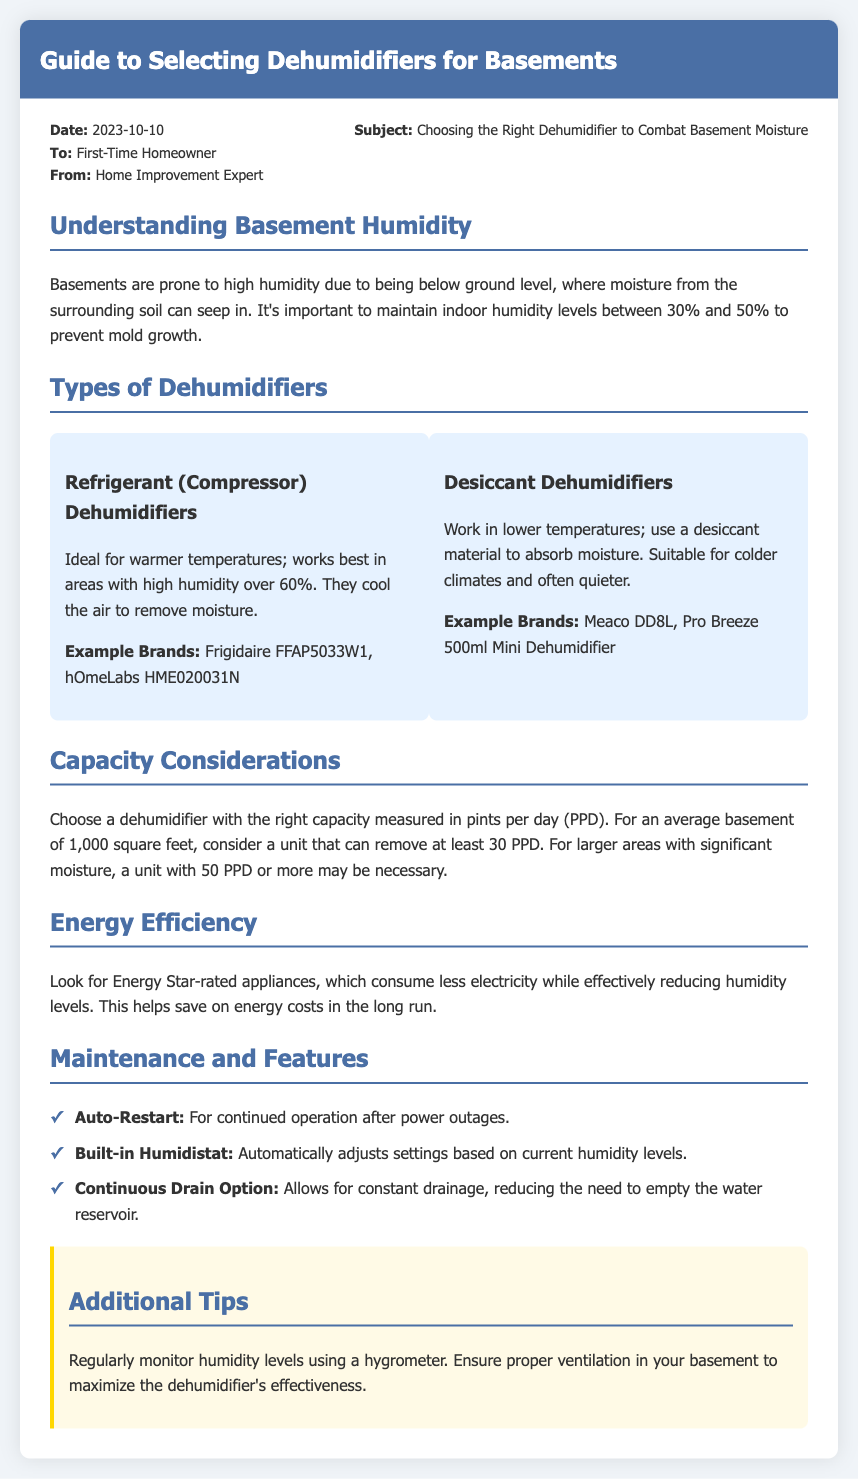what is the date of the memo? The memo states the date as 2023-10-10.
Answer: 2023-10-10 who is the memo addressed to? The memo is addressed to a First-Time Homeowner.
Answer: First-Time Homeowner what is the ideal indoor humidity range to prevent mold growth? The document mentions that humidity levels should be between 30% and 50%.
Answer: 30% and 50% which type of dehumidifier works best in warmer temperatures? The memo specifies that Refrigerant (Compressor) Dehumidifiers are ideal for warmer temperatures.
Answer: Refrigerant (Compressor) Dehumidifiers what is the recommended capacity for an average basement of 1,000 square feet? The memo advises considering a unit that can remove at least 30 PPD.
Answer: 30 PPD how can you save on energy costs when using a dehumidifier? The document suggests looking for Energy Star-rated appliances.
Answer: Energy Star-rated appliances what feature allows for the constant drainage of a dehumidifier? The memo mentions the Continuous Drain Option as a feature for constant drainage.
Answer: Continuous Drain Option what should you regularly monitor to ensure effective humidity control? The memo recommends regularly monitoring humidity levels using a hygrometer.
Answer: hygrometer 